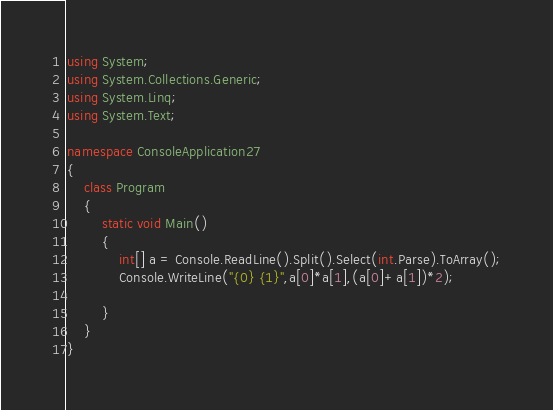Convert code to text. <code><loc_0><loc_0><loc_500><loc_500><_C#_>using System;
using System.Collections.Generic;
using System.Linq;
using System.Text;

namespace ConsoleApplication27
{
    class Program
    {
        static void Main()
        {
            int[] a = Console.ReadLine().Split().Select(int.Parse).ToArray();
            Console.WriteLine("{0} {1}",a[0]*a[1],(a[0]+a[1])*2);
           
        }
    }
}</code> 